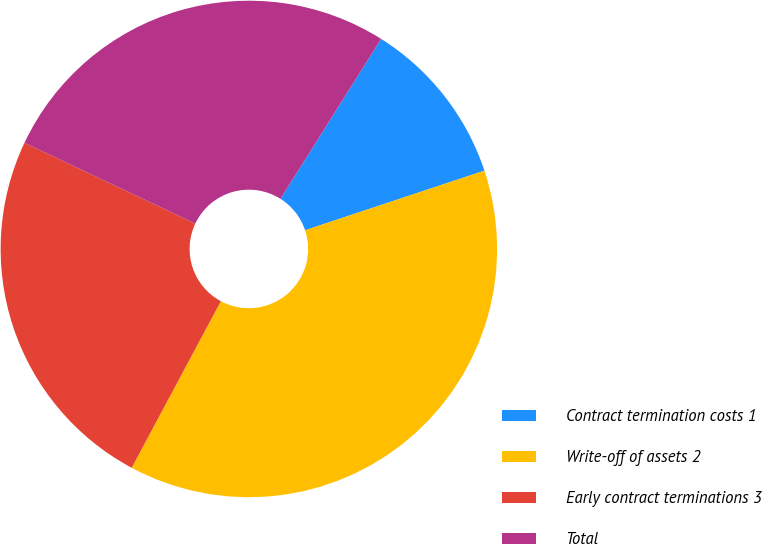Convert chart. <chart><loc_0><loc_0><loc_500><loc_500><pie_chart><fcel>Contract termination costs 1<fcel>Write-off of assets 2<fcel>Early contract terminations 3<fcel>Total<nl><fcel>10.95%<fcel>37.93%<fcel>24.21%<fcel>26.91%<nl></chart> 